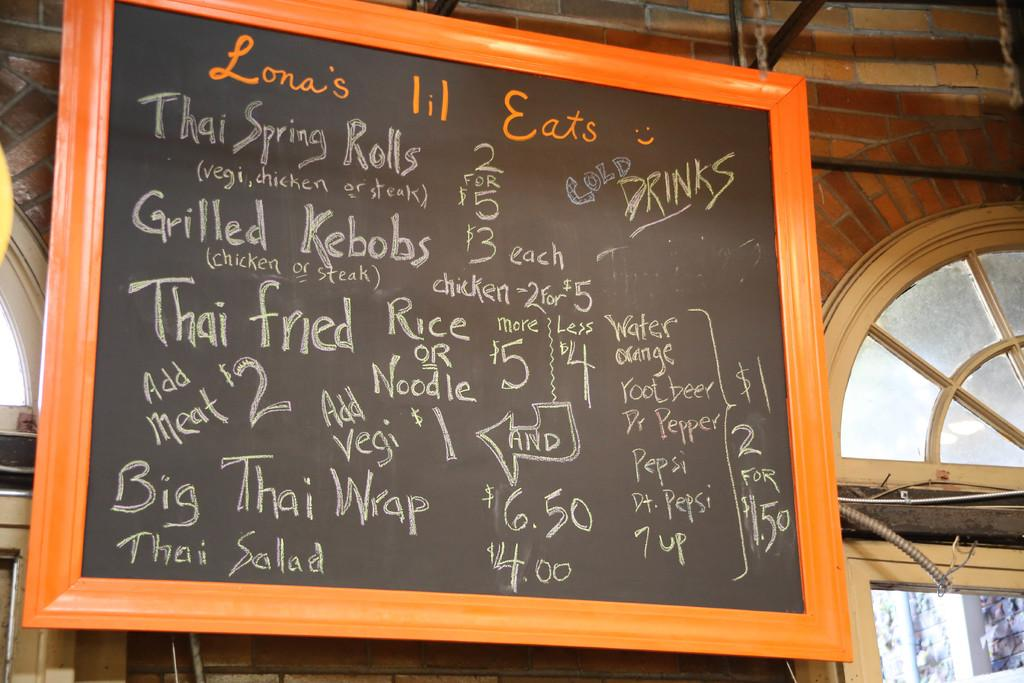What is on the wall in the image? There is a blackboard on the wall in the image. What is on the blackboard? There is writing on the blackboard. What color is the chalk used for the writing? The writing is done with white chalk. How many children are playing with the ball in the image? There is no ball or children present in the image. What is the size of the blackboard in the image? The size of the blackboard cannot be determined from the image alone. 